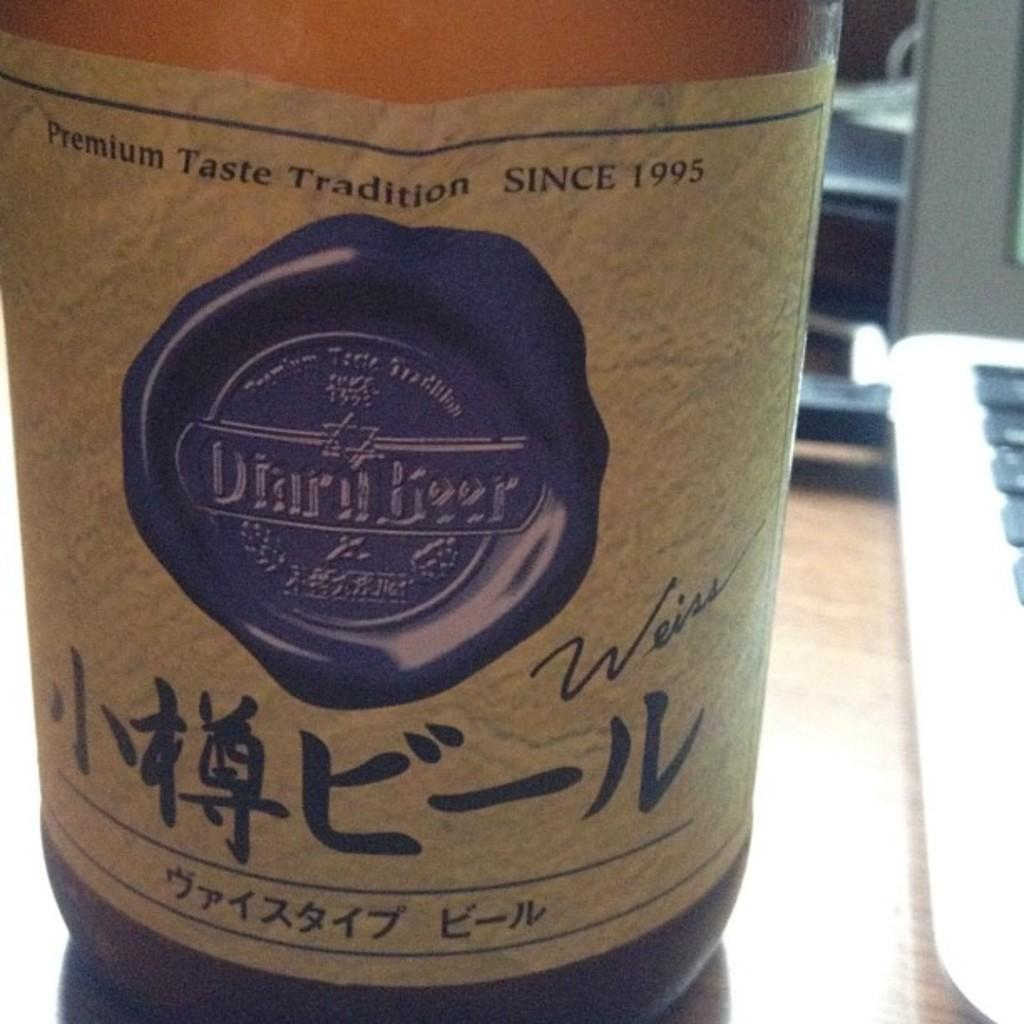What is the object with text on it in the image? There is a bottle with text in the image. Where is the bottle located? The bottle is placed on a table. What electronic device is present in the image? There is a laptop in the image. How is the laptop positioned in relation to the bottle? The laptop is beside the bottle. What type of apparatus is used to twist the bottle in the image? There is no apparatus used to twist the bottle in the image, as the bottle is stationary on the table. Can you see a gun in the image? No, there is no gun present in the image. 